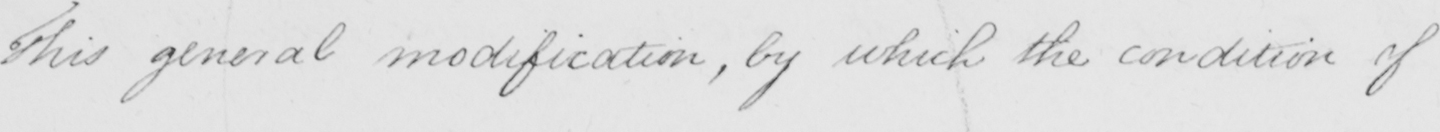What text is written in this handwritten line? This general modification , by which the condition of 